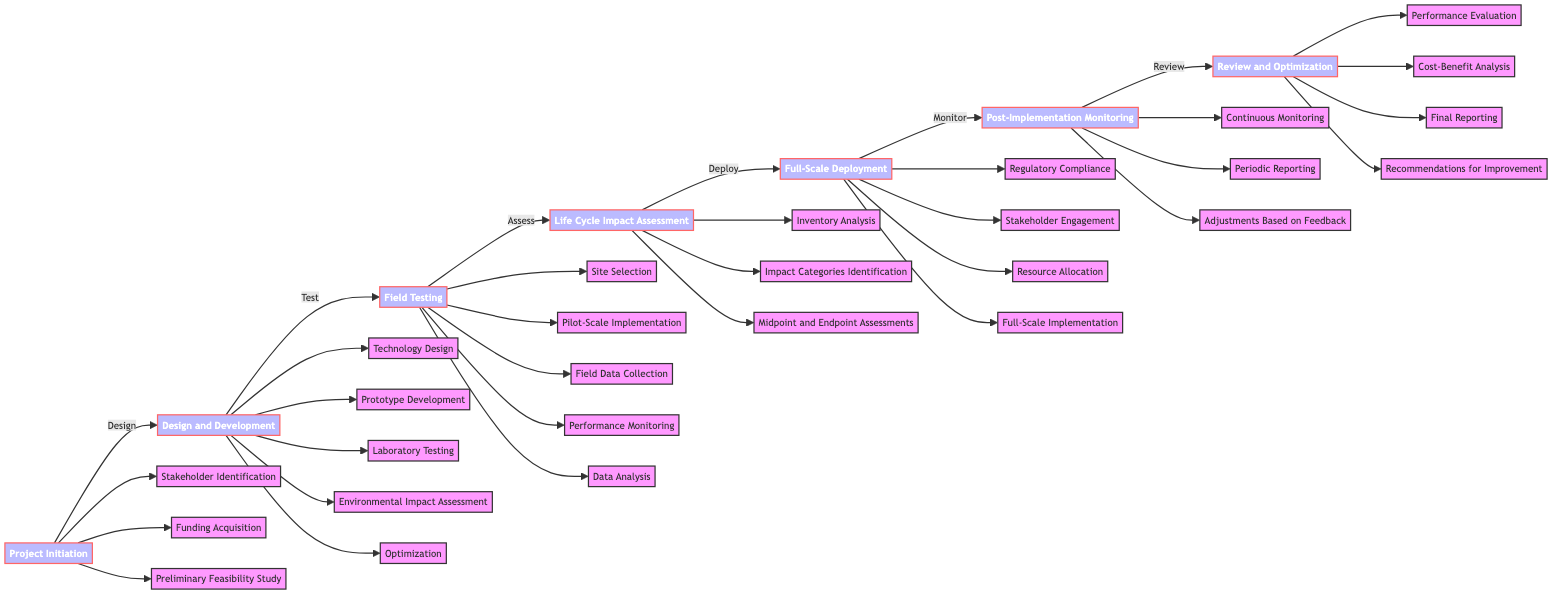What is the first phase in the life cycle assessment? The diagram shows that the first phase is "Project Initiation." It is the starting point of the flowchart, leading to the design phase.
Answer: Project Initiation How many tasks are listed under the "Design and Development" phase? The diagram indicates that there are five tasks listed under the "Design and Development" phase. They include Technology Design, Prototype Development, Laboratory Testing, Environmental Impact Assessment, and Optimization.
Answer: Five Which phase follows "Field Testing"? The diagram shows that after "Field Testing," the next phase is "Life Cycle Impact Assessment." This indicates a progression from testing to evaluating environmental impacts.
Answer: Life Cycle Impact Assessment What are the three main tasks in "Post-Implementation Monitoring"? According to the diagram, the three main tasks in "Post-Implementation Monitoring" are Continuous Monitoring, Periodic Reporting, and Adjustments Based on Feedback. These tasks focus on ensuring effectiveness and addressing ongoing issues.
Answer: Continuous Monitoring, Periodic Reporting, Adjustments Based on Feedback Which phase involves "Regulatory Compliance"? The diagram specifies that "Regulatory Compliance" is part of the "Full-Scale Deployment" phase. This indicates that ensuring regulations are met is crucial before the technology can be fully deployed.
Answer: Full-Scale Deployment How many total phases are represented in the flowchart? The diagram depicts six distinct phases in the life cycle assessment, each representing a critical step in the process from conception to deployment. The phases are Project Initiation, Design and Development, Field Testing, Life Cycle Impact Assessment, Full-Scale Deployment, and Post-Implementation Monitoring.
Answer: Six Which task from "Life Cycle Impact Assessment" focuses on environmental metrics? The task "Midpoint and Endpoint Assessments" from the "Life Cycle Impact Assessment" phase focuses specifically on evaluating environmental metrics, helping to understand the overall impact of the technology assessed.
Answer: Midpoint and Endpoint Assessments What comes after the "Review and Optimization" phase in the flowchart? The diagram does not indicate any additional phases after "Review and Optimization," suggesting it is the final phase in the flowchart. This implies that the cycle concludes with a review and optimization of the entire process.
Answer: None 